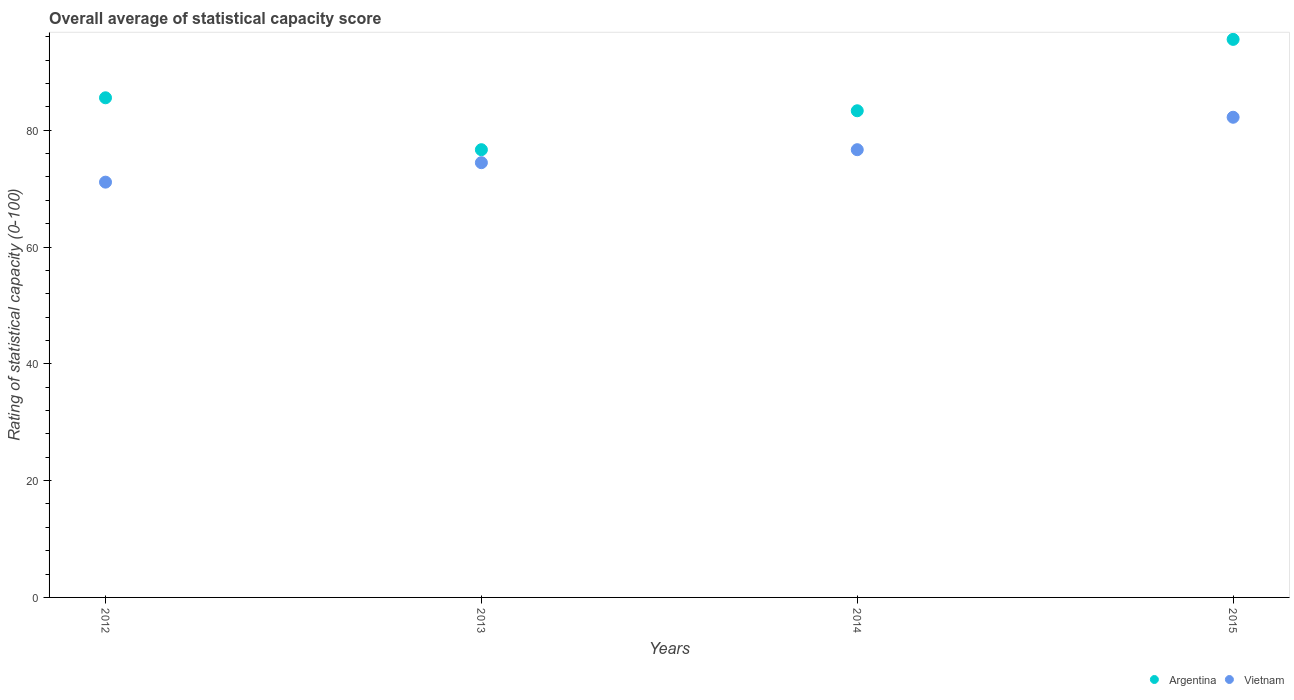How many different coloured dotlines are there?
Your answer should be very brief. 2. What is the rating of statistical capacity in Vietnam in 2013?
Provide a succinct answer. 74.44. Across all years, what is the maximum rating of statistical capacity in Vietnam?
Your answer should be compact. 82.22. Across all years, what is the minimum rating of statistical capacity in Vietnam?
Your answer should be very brief. 71.11. In which year was the rating of statistical capacity in Vietnam maximum?
Your answer should be compact. 2015. What is the total rating of statistical capacity in Vietnam in the graph?
Make the answer very short. 304.44. What is the difference between the rating of statistical capacity in Argentina in 2013 and that in 2015?
Provide a succinct answer. -18.89. What is the difference between the rating of statistical capacity in Argentina in 2015 and the rating of statistical capacity in Vietnam in 2014?
Offer a terse response. 18.89. What is the average rating of statistical capacity in Vietnam per year?
Offer a terse response. 76.11. In the year 2014, what is the difference between the rating of statistical capacity in Vietnam and rating of statistical capacity in Argentina?
Offer a terse response. -6.67. What is the ratio of the rating of statistical capacity in Argentina in 2012 to that in 2013?
Keep it short and to the point. 1.12. Is the difference between the rating of statistical capacity in Vietnam in 2013 and 2015 greater than the difference between the rating of statistical capacity in Argentina in 2013 and 2015?
Your answer should be very brief. Yes. What is the difference between the highest and the second highest rating of statistical capacity in Vietnam?
Offer a very short reply. 5.56. What is the difference between the highest and the lowest rating of statistical capacity in Vietnam?
Provide a short and direct response. 11.11. Is the rating of statistical capacity in Vietnam strictly greater than the rating of statistical capacity in Argentina over the years?
Keep it short and to the point. No. Are the values on the major ticks of Y-axis written in scientific E-notation?
Give a very brief answer. No. Where does the legend appear in the graph?
Offer a very short reply. Bottom right. How many legend labels are there?
Your response must be concise. 2. What is the title of the graph?
Make the answer very short. Overall average of statistical capacity score. Does "Denmark" appear as one of the legend labels in the graph?
Offer a terse response. No. What is the label or title of the Y-axis?
Provide a short and direct response. Rating of statistical capacity (0-100). What is the Rating of statistical capacity (0-100) of Argentina in 2012?
Keep it short and to the point. 85.56. What is the Rating of statistical capacity (0-100) of Vietnam in 2012?
Give a very brief answer. 71.11. What is the Rating of statistical capacity (0-100) of Argentina in 2013?
Keep it short and to the point. 76.67. What is the Rating of statistical capacity (0-100) in Vietnam in 2013?
Provide a succinct answer. 74.44. What is the Rating of statistical capacity (0-100) in Argentina in 2014?
Your response must be concise. 83.33. What is the Rating of statistical capacity (0-100) of Vietnam in 2014?
Provide a short and direct response. 76.67. What is the Rating of statistical capacity (0-100) in Argentina in 2015?
Ensure brevity in your answer.  95.56. What is the Rating of statistical capacity (0-100) in Vietnam in 2015?
Provide a succinct answer. 82.22. Across all years, what is the maximum Rating of statistical capacity (0-100) of Argentina?
Offer a terse response. 95.56. Across all years, what is the maximum Rating of statistical capacity (0-100) of Vietnam?
Your answer should be very brief. 82.22. Across all years, what is the minimum Rating of statistical capacity (0-100) of Argentina?
Your response must be concise. 76.67. Across all years, what is the minimum Rating of statistical capacity (0-100) of Vietnam?
Offer a very short reply. 71.11. What is the total Rating of statistical capacity (0-100) of Argentina in the graph?
Provide a succinct answer. 341.11. What is the total Rating of statistical capacity (0-100) of Vietnam in the graph?
Provide a short and direct response. 304.44. What is the difference between the Rating of statistical capacity (0-100) of Argentina in 2012 and that in 2013?
Offer a terse response. 8.89. What is the difference between the Rating of statistical capacity (0-100) of Argentina in 2012 and that in 2014?
Your answer should be very brief. 2.22. What is the difference between the Rating of statistical capacity (0-100) of Vietnam in 2012 and that in 2014?
Provide a succinct answer. -5.56. What is the difference between the Rating of statistical capacity (0-100) of Vietnam in 2012 and that in 2015?
Ensure brevity in your answer.  -11.11. What is the difference between the Rating of statistical capacity (0-100) in Argentina in 2013 and that in 2014?
Your response must be concise. -6.67. What is the difference between the Rating of statistical capacity (0-100) of Vietnam in 2013 and that in 2014?
Ensure brevity in your answer.  -2.22. What is the difference between the Rating of statistical capacity (0-100) of Argentina in 2013 and that in 2015?
Give a very brief answer. -18.89. What is the difference between the Rating of statistical capacity (0-100) of Vietnam in 2013 and that in 2015?
Ensure brevity in your answer.  -7.78. What is the difference between the Rating of statistical capacity (0-100) of Argentina in 2014 and that in 2015?
Offer a terse response. -12.22. What is the difference between the Rating of statistical capacity (0-100) in Vietnam in 2014 and that in 2015?
Keep it short and to the point. -5.56. What is the difference between the Rating of statistical capacity (0-100) of Argentina in 2012 and the Rating of statistical capacity (0-100) of Vietnam in 2013?
Keep it short and to the point. 11.11. What is the difference between the Rating of statistical capacity (0-100) of Argentina in 2012 and the Rating of statistical capacity (0-100) of Vietnam in 2014?
Ensure brevity in your answer.  8.89. What is the difference between the Rating of statistical capacity (0-100) of Argentina in 2013 and the Rating of statistical capacity (0-100) of Vietnam in 2014?
Give a very brief answer. 0. What is the difference between the Rating of statistical capacity (0-100) of Argentina in 2013 and the Rating of statistical capacity (0-100) of Vietnam in 2015?
Your answer should be compact. -5.56. What is the average Rating of statistical capacity (0-100) of Argentina per year?
Your answer should be very brief. 85.28. What is the average Rating of statistical capacity (0-100) in Vietnam per year?
Provide a short and direct response. 76.11. In the year 2012, what is the difference between the Rating of statistical capacity (0-100) in Argentina and Rating of statistical capacity (0-100) in Vietnam?
Offer a very short reply. 14.44. In the year 2013, what is the difference between the Rating of statistical capacity (0-100) in Argentina and Rating of statistical capacity (0-100) in Vietnam?
Ensure brevity in your answer.  2.22. In the year 2015, what is the difference between the Rating of statistical capacity (0-100) of Argentina and Rating of statistical capacity (0-100) of Vietnam?
Your response must be concise. 13.33. What is the ratio of the Rating of statistical capacity (0-100) of Argentina in 2012 to that in 2013?
Ensure brevity in your answer.  1.12. What is the ratio of the Rating of statistical capacity (0-100) in Vietnam in 2012 to that in 2013?
Your response must be concise. 0.96. What is the ratio of the Rating of statistical capacity (0-100) of Argentina in 2012 to that in 2014?
Your answer should be compact. 1.03. What is the ratio of the Rating of statistical capacity (0-100) of Vietnam in 2012 to that in 2014?
Offer a very short reply. 0.93. What is the ratio of the Rating of statistical capacity (0-100) in Argentina in 2012 to that in 2015?
Provide a short and direct response. 0.9. What is the ratio of the Rating of statistical capacity (0-100) of Vietnam in 2012 to that in 2015?
Provide a succinct answer. 0.86. What is the ratio of the Rating of statistical capacity (0-100) in Argentina in 2013 to that in 2015?
Provide a succinct answer. 0.8. What is the ratio of the Rating of statistical capacity (0-100) in Vietnam in 2013 to that in 2015?
Offer a terse response. 0.91. What is the ratio of the Rating of statistical capacity (0-100) in Argentina in 2014 to that in 2015?
Keep it short and to the point. 0.87. What is the ratio of the Rating of statistical capacity (0-100) of Vietnam in 2014 to that in 2015?
Make the answer very short. 0.93. What is the difference between the highest and the second highest Rating of statistical capacity (0-100) of Argentina?
Ensure brevity in your answer.  10. What is the difference between the highest and the second highest Rating of statistical capacity (0-100) of Vietnam?
Provide a succinct answer. 5.56. What is the difference between the highest and the lowest Rating of statistical capacity (0-100) in Argentina?
Make the answer very short. 18.89. What is the difference between the highest and the lowest Rating of statistical capacity (0-100) in Vietnam?
Provide a short and direct response. 11.11. 